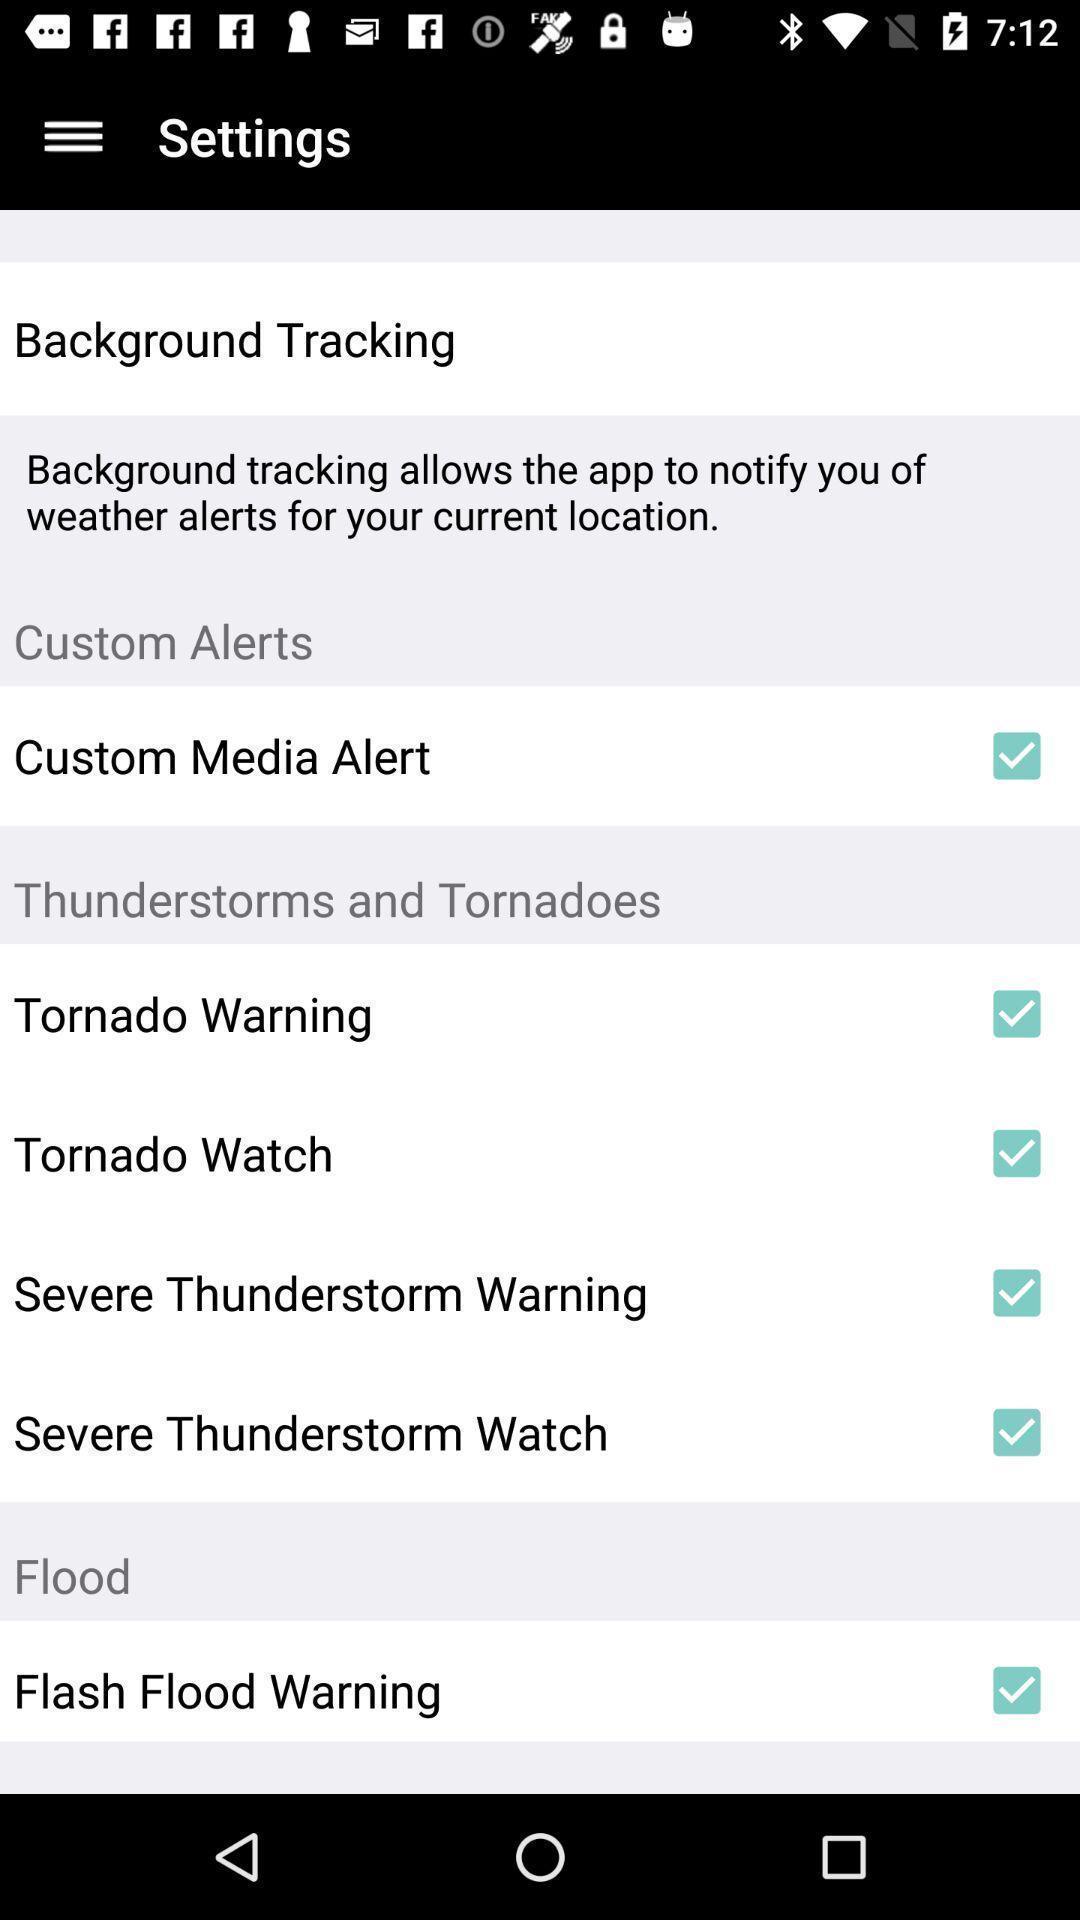Summarize the information in this screenshot. Settings tab with different kinds of options. 